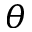Convert formula to latex. <formula><loc_0><loc_0><loc_500><loc_500>\theta</formula> 